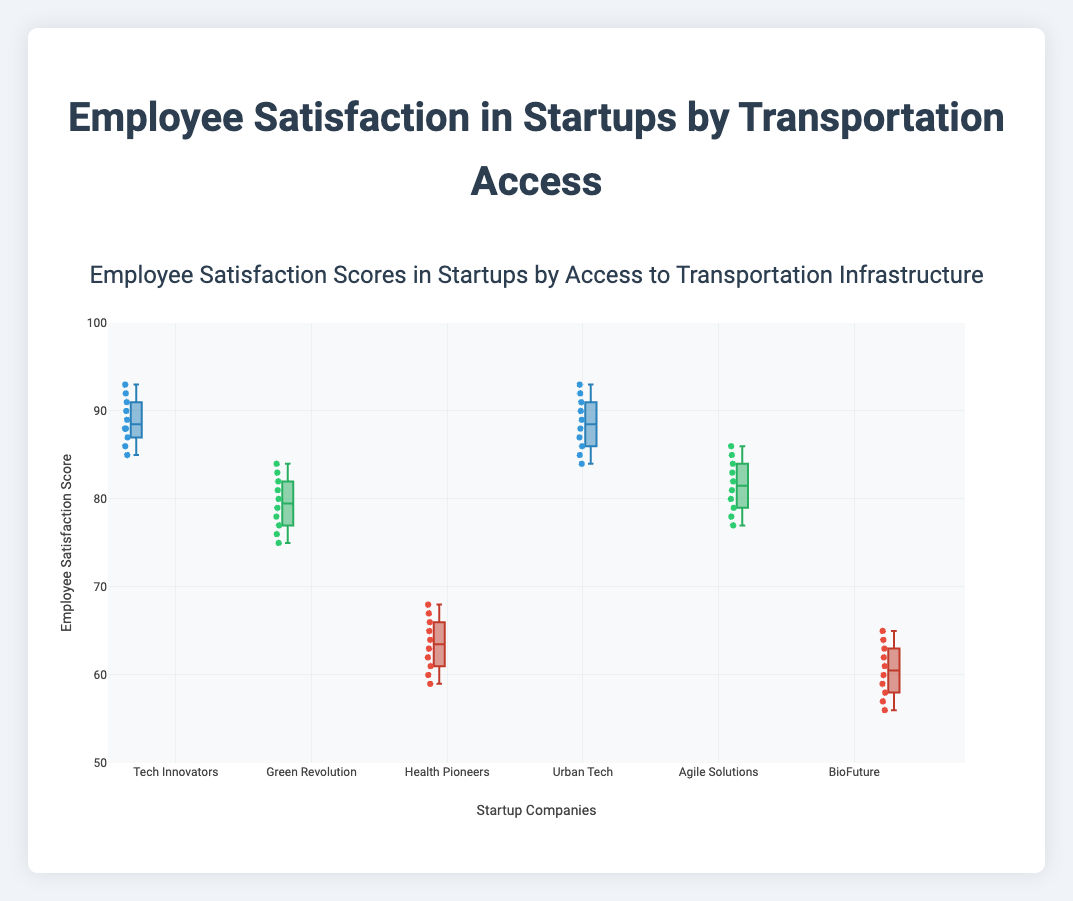How many startup companies are shown in the figure? The figure displays the names of the startup companies along the x-axis. By counting these names, we get the total number of companies.
Answer: 6 What is the range of employee satisfaction scores for startups with high access to transportation? For startups with high access to transportation ("Tech Innovators" and "Urban Tech"), find the minimum and maximum values among their employee satisfaction scores. The range is from the lowest to the highest score.
Answer: 84 to 93 Which startup has the highest median employee satisfaction score? The median score is the middle value when the data is ordered. For each company, locate the median value on their box plot. Compare these medians and identify the highest one.
Answer: Tech Innovators What is the interquartile range (IQR) for "Green Revolution"? The IQR is the difference between the third quartile (Q3) and the first quartile (Q1) of the dataset. Locate Q1 and Q3 for "Green Revolution" from its box plot, and calculate the difference.
Answer: 9 (82 - 73) How do the employee satisfaction scores for companies with low access to transportation compare to those with medium access? Look at the distribution of scores in the box plots for the companies with low access ("Health Pioneers" and "BioFuture") compared to the medium access companies ("Green Revolution" and "Agile Solutions"). Assess overall score range, median, and spread.
Answer: Low is lower Which startup has the smallest spread in employee satisfaction scores? The spread is indicated by the length of the box in the box plot. Identify the company whose box (from Q1 to Q3) is the shortest.
Answer: Urban Tech For "Agile Solutions," what is the difference between the maximum and the median employee satisfaction score? Identify the maximum value and the median (middle value) in the box plot for "Agile Solutions." Subtract the median from the maximum.
Answer: 7 (86 - 79) What can you infer about employee satisfaction in relation to transportation access from the box plots? Observe the central tendency (median) and spread (interquartile range) of the box plots for different transportation access levels (high, medium, low).
Answer: Higher access correlates with higher satisfaction Which company has the greatest variability in employee satisfaction scores? Variability can be assessed by looking at the total range (difference between maximum and minimum) and overall position of the whiskers in the box plot. Identify the company with the greatest range.
Answer: BioFuture 